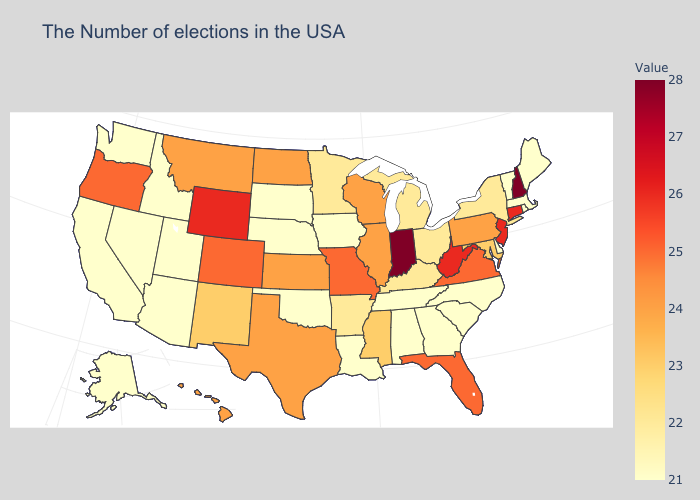Does Illinois have the highest value in the MidWest?
Quick response, please. No. Does Montana have a lower value than Indiana?
Write a very short answer. Yes. Which states have the highest value in the USA?
Short answer required. New Hampshire, Indiana. Which states have the highest value in the USA?
Be succinct. New Hampshire, Indiana. Does Kentucky have the highest value in the USA?
Concise answer only. No. Which states have the lowest value in the USA?
Quick response, please. Maine, Massachusetts, Rhode Island, Vermont, Delaware, North Carolina, South Carolina, Georgia, Alabama, Tennessee, Louisiana, Iowa, Nebraska, Oklahoma, South Dakota, Utah, Arizona, Idaho, Nevada, California, Washington, Alaska. Which states have the lowest value in the West?
Be succinct. Utah, Arizona, Idaho, Nevada, California, Washington, Alaska. Does the map have missing data?
Concise answer only. No. Does Indiana have the highest value in the MidWest?
Answer briefly. Yes. Which states have the highest value in the USA?
Answer briefly. New Hampshire, Indiana. 